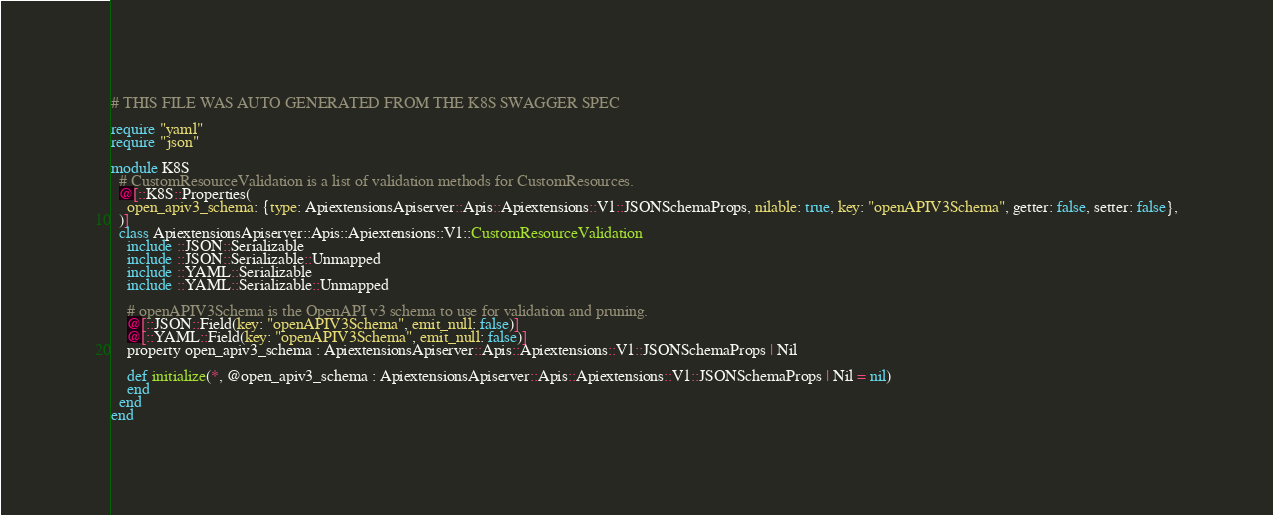<code> <loc_0><loc_0><loc_500><loc_500><_Crystal_># THIS FILE WAS AUTO GENERATED FROM THE K8S SWAGGER SPEC

require "yaml"
require "json"

module K8S
  # CustomResourceValidation is a list of validation methods for CustomResources.
  @[::K8S::Properties(
    open_apiv3_schema: {type: ApiextensionsApiserver::Apis::Apiextensions::V1::JSONSchemaProps, nilable: true, key: "openAPIV3Schema", getter: false, setter: false},
  )]
  class ApiextensionsApiserver::Apis::Apiextensions::V1::CustomResourceValidation
    include ::JSON::Serializable
    include ::JSON::Serializable::Unmapped
    include ::YAML::Serializable
    include ::YAML::Serializable::Unmapped

    # openAPIV3Schema is the OpenAPI v3 schema to use for validation and pruning.
    @[::JSON::Field(key: "openAPIV3Schema", emit_null: false)]
    @[::YAML::Field(key: "openAPIV3Schema", emit_null: false)]
    property open_apiv3_schema : ApiextensionsApiserver::Apis::Apiextensions::V1::JSONSchemaProps | Nil

    def initialize(*, @open_apiv3_schema : ApiextensionsApiserver::Apis::Apiextensions::V1::JSONSchemaProps | Nil = nil)
    end
  end
end
</code> 